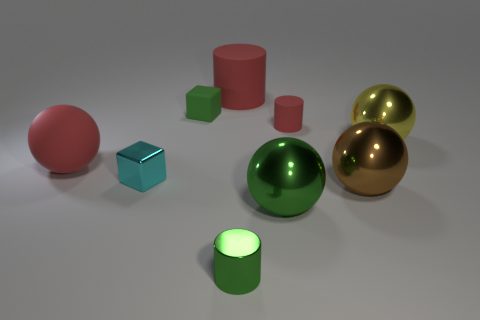There is a matte object that is the same shape as the cyan shiny object; what color is it?
Provide a short and direct response. Green. What number of cylinders have the same color as the matte cube?
Your answer should be compact. 1. Do the big matte cylinder and the large metal thing that is on the right side of the brown object have the same color?
Provide a succinct answer. No. There is a big object that is in front of the cyan metallic object and on the left side of the large brown metallic ball; what is its shape?
Offer a very short reply. Sphere. The green thing that is behind the big green ball in front of the tiny green thing that is behind the large yellow thing is made of what material?
Provide a succinct answer. Rubber. Are there more tiny matte blocks that are to the left of the small rubber block than green blocks that are behind the yellow metallic ball?
Make the answer very short. No. How many small red cylinders have the same material as the big green thing?
Give a very brief answer. 0. Is the shape of the brown shiny object that is in front of the small green matte object the same as the red object that is in front of the big yellow object?
Your response must be concise. Yes. What color is the small cylinder that is in front of the metallic cube?
Ensure brevity in your answer.  Green. Are there any brown matte things of the same shape as the yellow object?
Your answer should be very brief. No. 